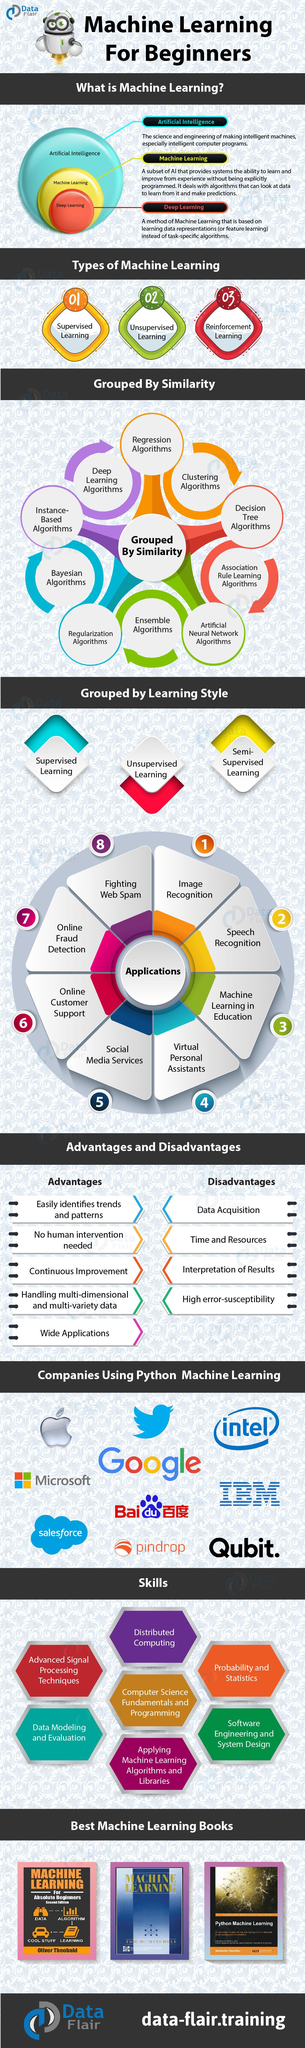Point out several critical features in this image. Sebastian Raschka is the author of Python Machine Learning. Three types of machine learning are presented. Machine learning involves the use of various algorithms to enable computers to learn and improve their performance on a specific task without being explicitly programmed. There have been a total of 8 instances where Machine Learning has been applied. Oliver Theobald has authored the listed book "Machine Learning For Absolute Beginners. 